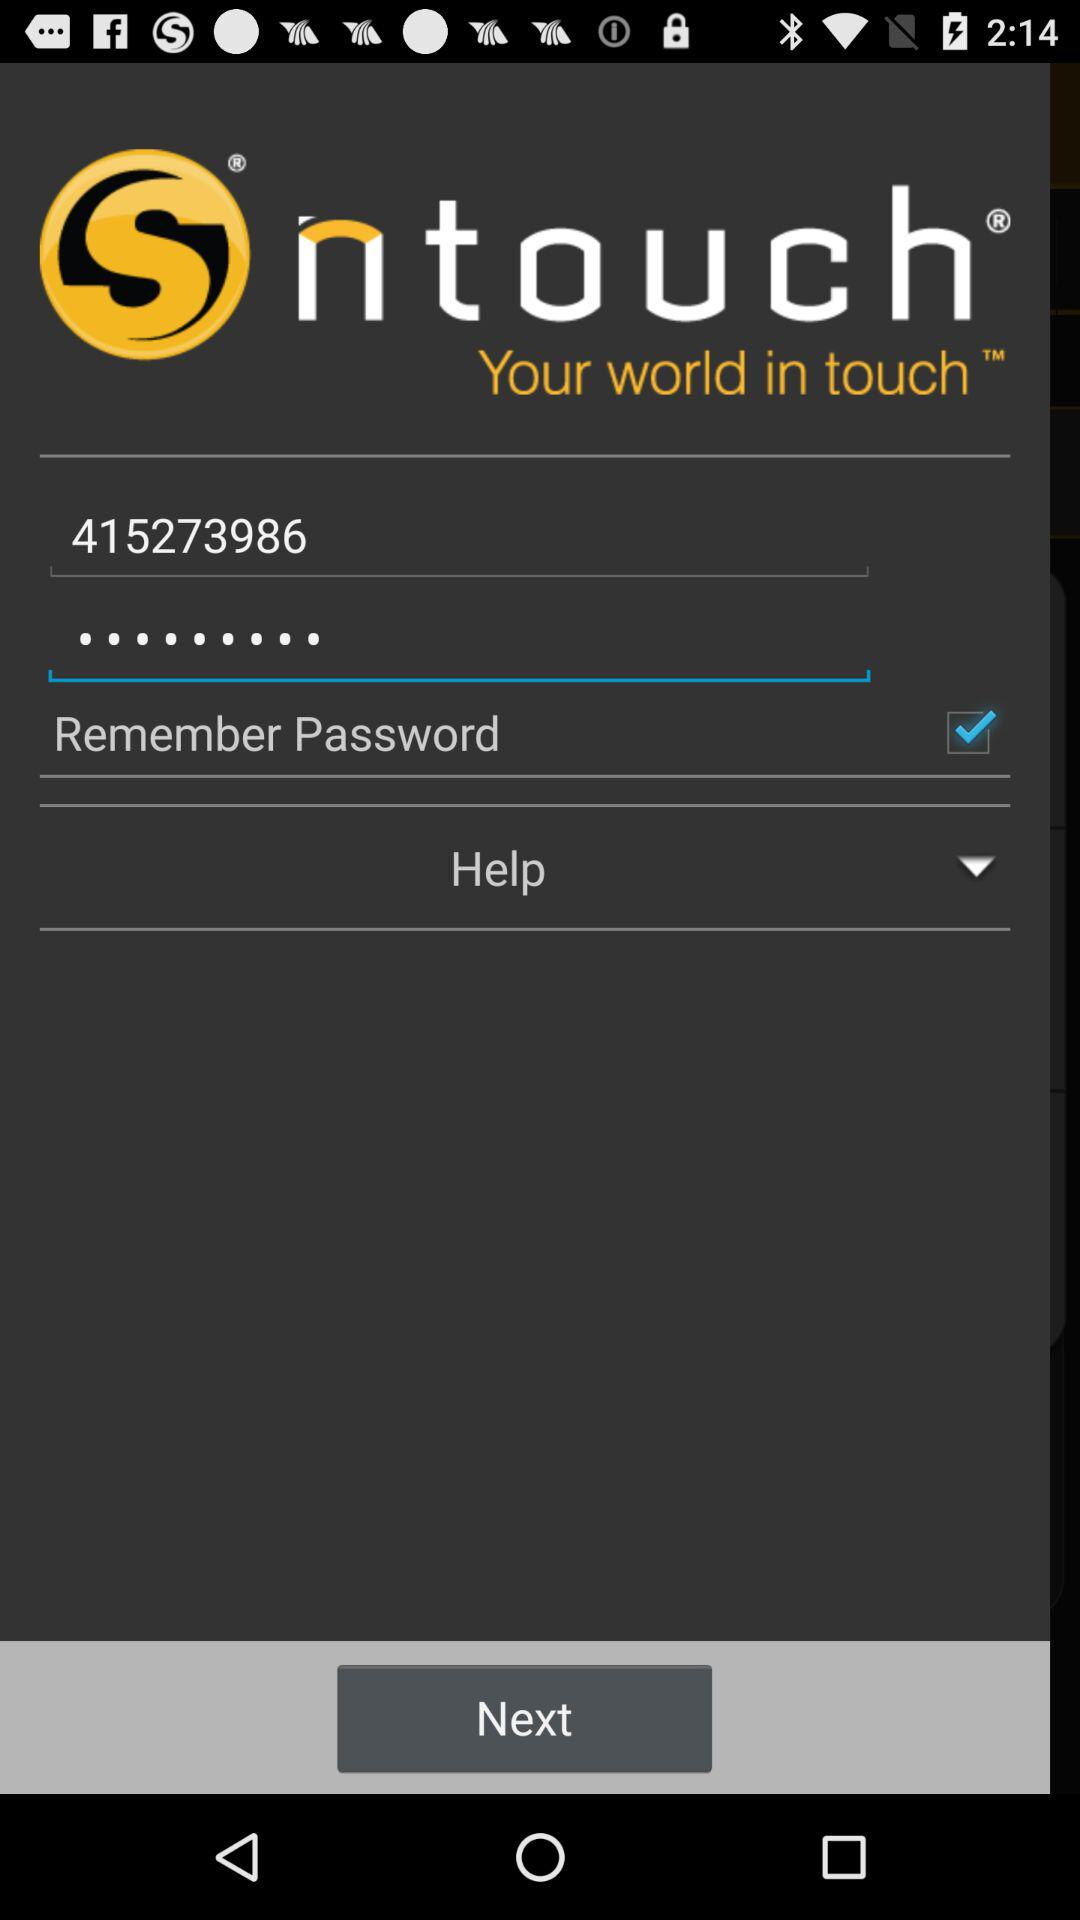What is the status of "Remember Password"? The status of "Remember Password" is "on". 